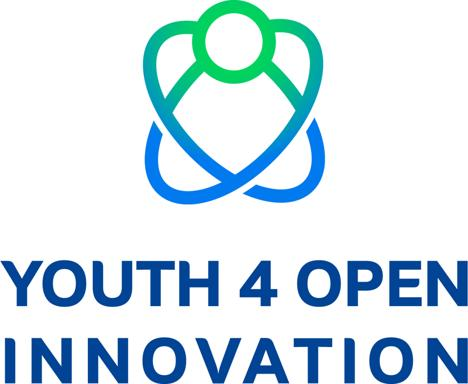What do the colors in the logo symbolize? The blue and green colors in the logo are often associated with qualities such as creativity, growth, and vitality. Blue can represent trust, dependability, and wisdom, which are important values in fostering open innovation. Green typically symbolizes renewal and harmony, reflecting the fresh perspectives and sustainable practices promoted by youth in innovation. And the significance of the figure in the logo? The figure in the logo captures the essence of human-centric innovation, highlighting the role of individual creativity and collaboration in the open innovation process. The circular arrangement around the figure may imply inclusivity and unity, conceptualizing a global community coming together for a common purpose. 